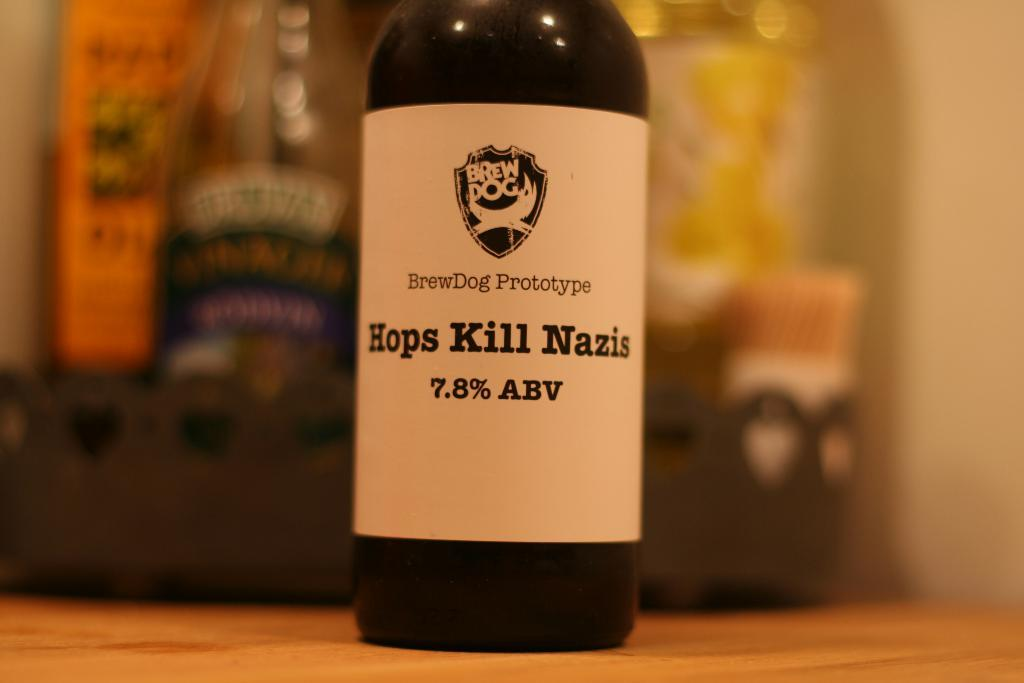<image>
Create a compact narrative representing the image presented. The bottle of Hops Kill Nazis that is on a wooden surface has 7.8% alcohol by volume. 